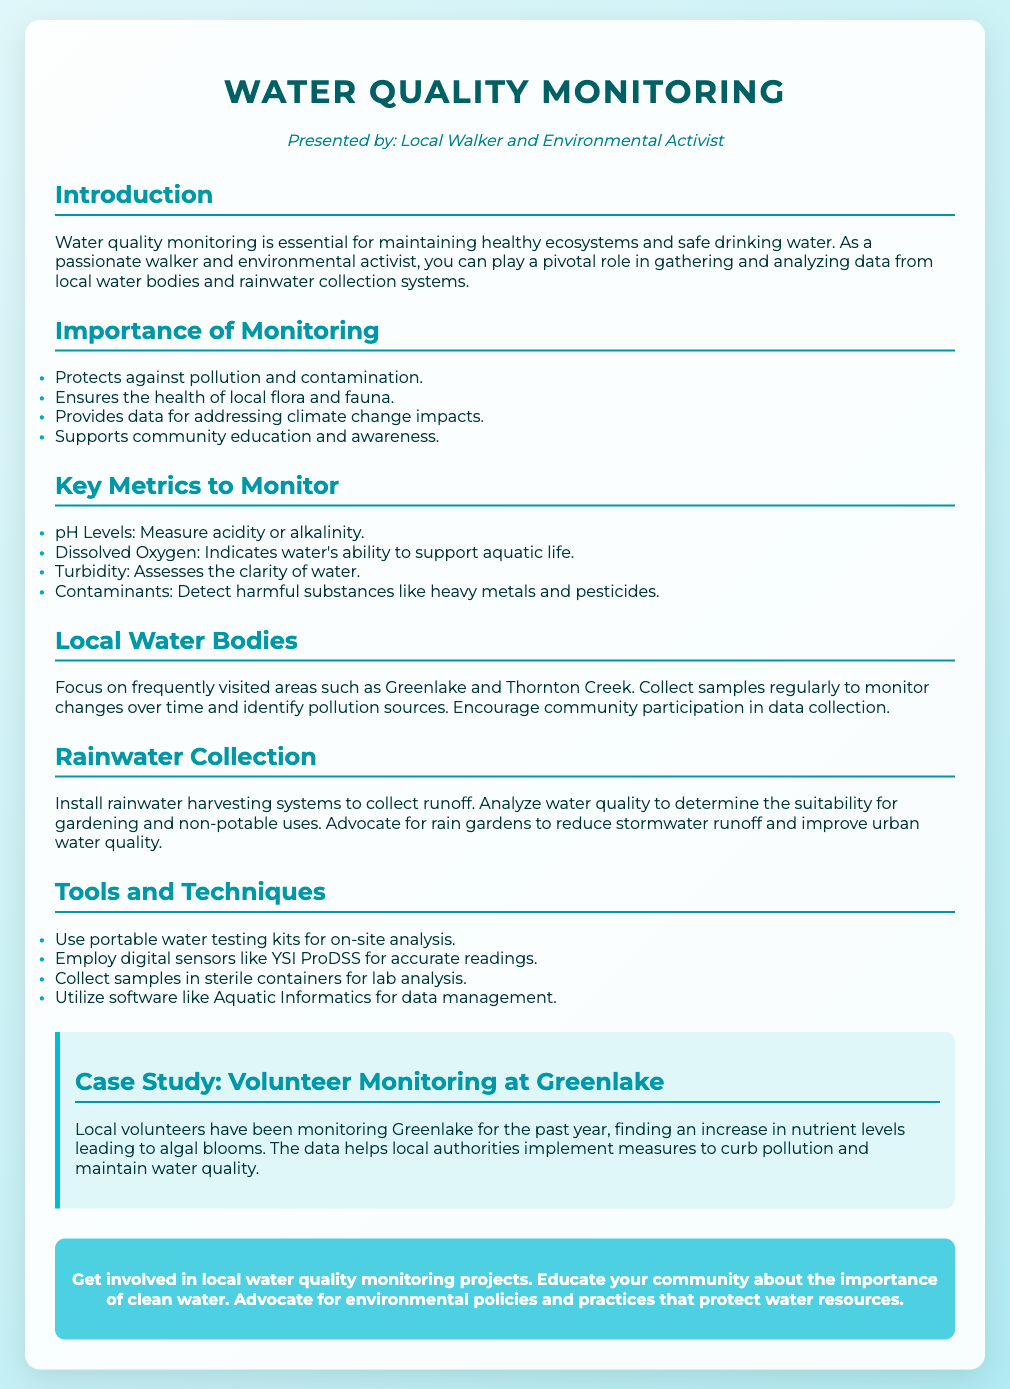what is the title of the presentation? The title is prominently displayed at the top of the slide as the main heading.
Answer: Water Quality Monitoring who is the presenter of the slide? The presenter's name is mentioned in the introductory section of the slide.
Answer: Local Walker and Environmental Activist which water bodies are mentioned for monitoring? The document lists specific local areas that are important for monitoring the water quality.
Answer: Greenlake and Thornton Creek what is a key metric to monitor for aquatic life? The document identifies several important metrics for assessing water quality.
Answer: Dissolved Oxygen what tool is suggested for on-site water analysis? The slide mentions a specific type of tool recommended for testing water quality directly.
Answer: portable water testing kits why is monitoring water quality important? This section outlines several reasons supporting the necessity of monitoring water quality in the environment.
Answer: Protects against pollution and contamination what is indicated by increased nutrient levels at Greenlake? The case study describes a specific environmental issue linked to water quality monitoring results.
Answer: algal blooms what is a suggested action for community involvement? The call to action emphasizes participation and advocacy from the community.
Answer: Get involved in local water quality monitoring projects 